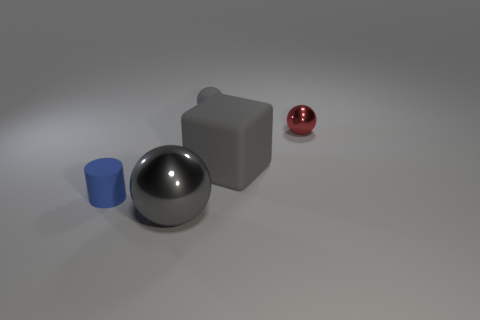The gray thing that is the same size as the gray shiny ball is what shape?
Provide a succinct answer. Cube. What material is the tiny object that is to the left of the gray thing behind the sphere that is to the right of the tiny matte ball made of?
Provide a succinct answer. Rubber. Do the red sphere and the blue cylinder have the same size?
Give a very brief answer. Yes. What is the material of the blue thing?
Your answer should be compact. Rubber. What is the material of the tiny sphere that is the same color as the rubber cube?
Your answer should be compact. Rubber. Is the shape of the metal object in front of the red sphere the same as  the red object?
Keep it short and to the point. Yes. What number of objects are small cyan metallic cylinders or tiny red spheres?
Your answer should be very brief. 1. Do the gray ball behind the large gray sphere and the blue object have the same material?
Provide a succinct answer. Yes. What size is the blue object?
Your response must be concise. Small. The large rubber thing that is the same color as the big metallic sphere is what shape?
Keep it short and to the point. Cube. 